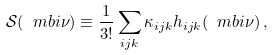<formula> <loc_0><loc_0><loc_500><loc_500>\mathcal { S } ( \ m b i \nu ) \equiv \frac { 1 } { 3 ! } \sum _ { i j k } \kappa _ { i j k } { h } _ { i j k } ( \ m b i \nu ) \, ,</formula> 